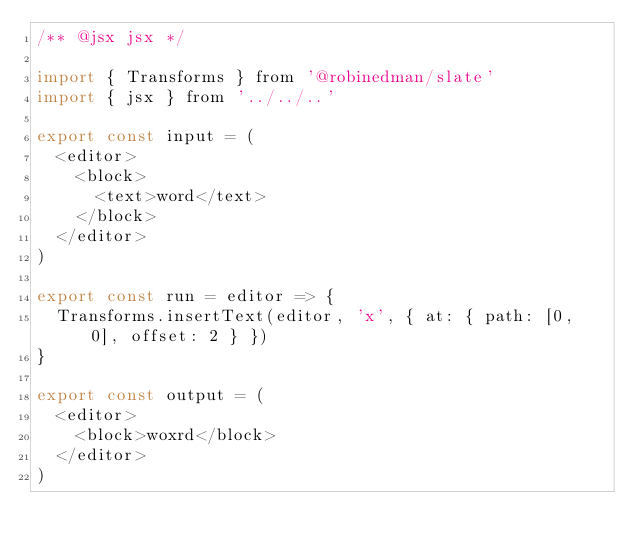<code> <loc_0><loc_0><loc_500><loc_500><_JavaScript_>/** @jsx jsx */

import { Transforms } from '@robinedman/slate'
import { jsx } from '../../..'

export const input = (
  <editor>
    <block>
      <text>word</text>
    </block>
  </editor>
)

export const run = editor => {
  Transforms.insertText(editor, 'x', { at: { path: [0, 0], offset: 2 } })
}

export const output = (
  <editor>
    <block>woxrd</block>
  </editor>
)
</code> 